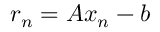<formula> <loc_0><loc_0><loc_500><loc_500>r _ { n } = A x _ { n } - b</formula> 